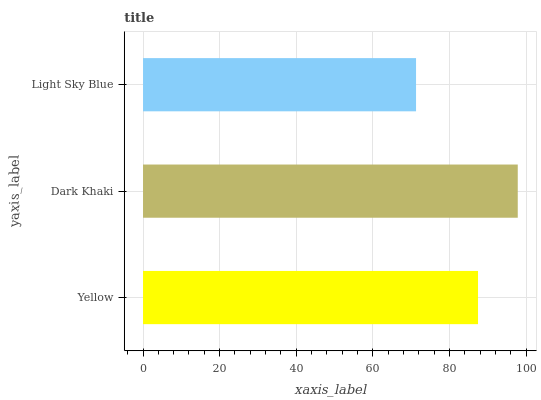Is Light Sky Blue the minimum?
Answer yes or no. Yes. Is Dark Khaki the maximum?
Answer yes or no. Yes. Is Dark Khaki the minimum?
Answer yes or no. No. Is Light Sky Blue the maximum?
Answer yes or no. No. Is Dark Khaki greater than Light Sky Blue?
Answer yes or no. Yes. Is Light Sky Blue less than Dark Khaki?
Answer yes or no. Yes. Is Light Sky Blue greater than Dark Khaki?
Answer yes or no. No. Is Dark Khaki less than Light Sky Blue?
Answer yes or no. No. Is Yellow the high median?
Answer yes or no. Yes. Is Yellow the low median?
Answer yes or no. Yes. Is Dark Khaki the high median?
Answer yes or no. No. Is Light Sky Blue the low median?
Answer yes or no. No. 